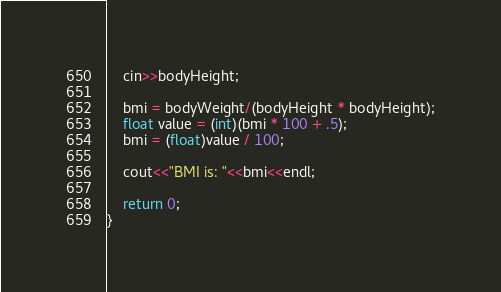<code> <loc_0><loc_0><loc_500><loc_500><_C++_>    cin>>bodyHeight;

    bmi = bodyWeight/(bodyHeight * bodyHeight);
    float value = (int)(bmi * 100 + .5);
    bmi = (float)value / 100;

    cout<<"BMI is: "<<bmi<<endl;

    return 0;
}</code> 